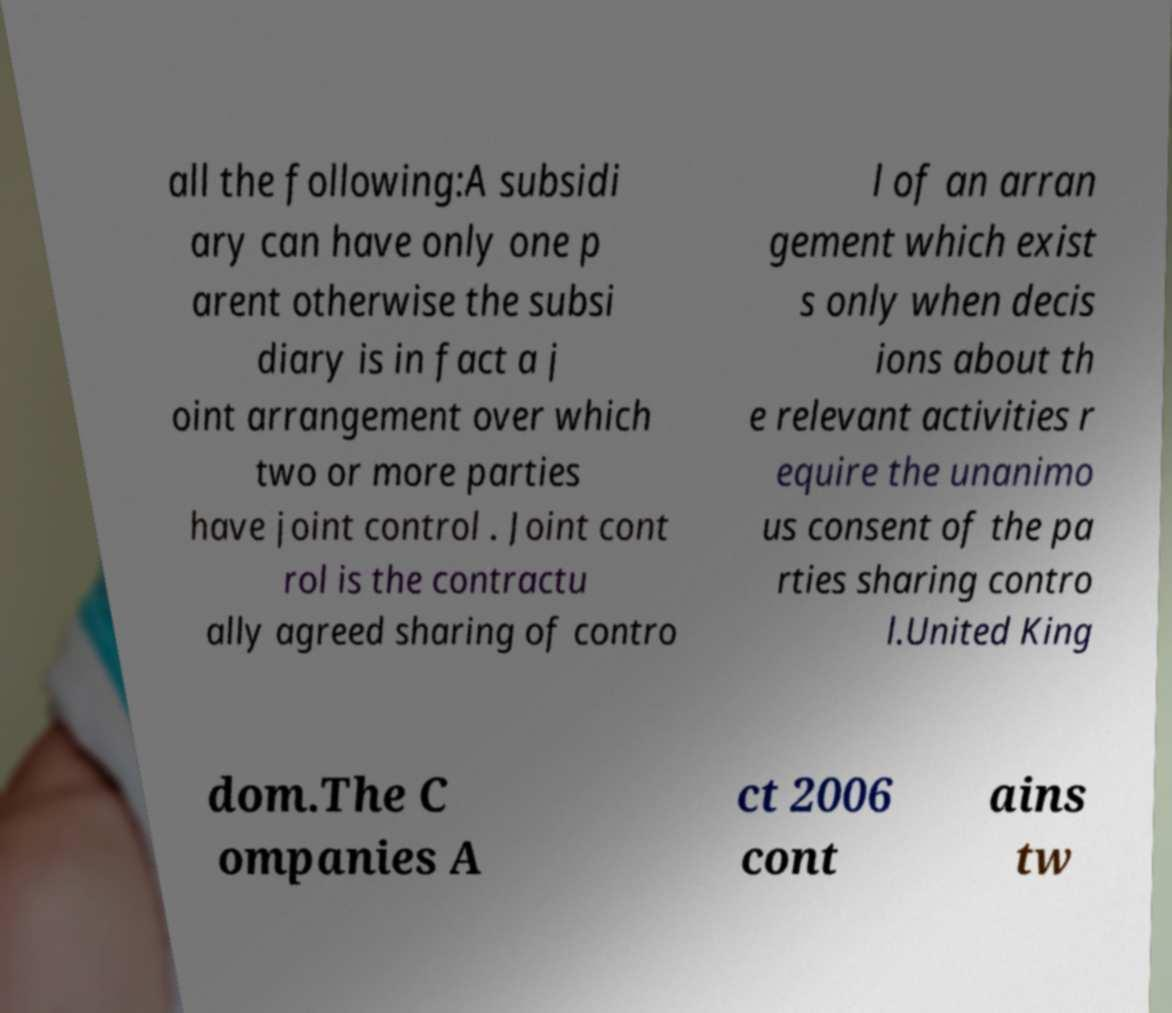Could you extract and type out the text from this image? all the following:A subsidi ary can have only one p arent otherwise the subsi diary is in fact a j oint arrangement over which two or more parties have joint control . Joint cont rol is the contractu ally agreed sharing of contro l of an arran gement which exist s only when decis ions about th e relevant activities r equire the unanimo us consent of the pa rties sharing contro l.United King dom.The C ompanies A ct 2006 cont ains tw 